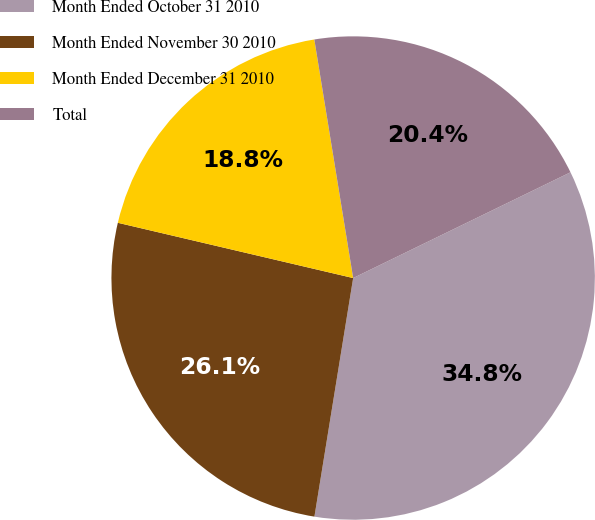<chart> <loc_0><loc_0><loc_500><loc_500><pie_chart><fcel>Month Ended October 31 2010<fcel>Month Ended November 30 2010<fcel>Month Ended December 31 2010<fcel>Total<nl><fcel>34.77%<fcel>26.11%<fcel>18.76%<fcel>20.36%<nl></chart> 